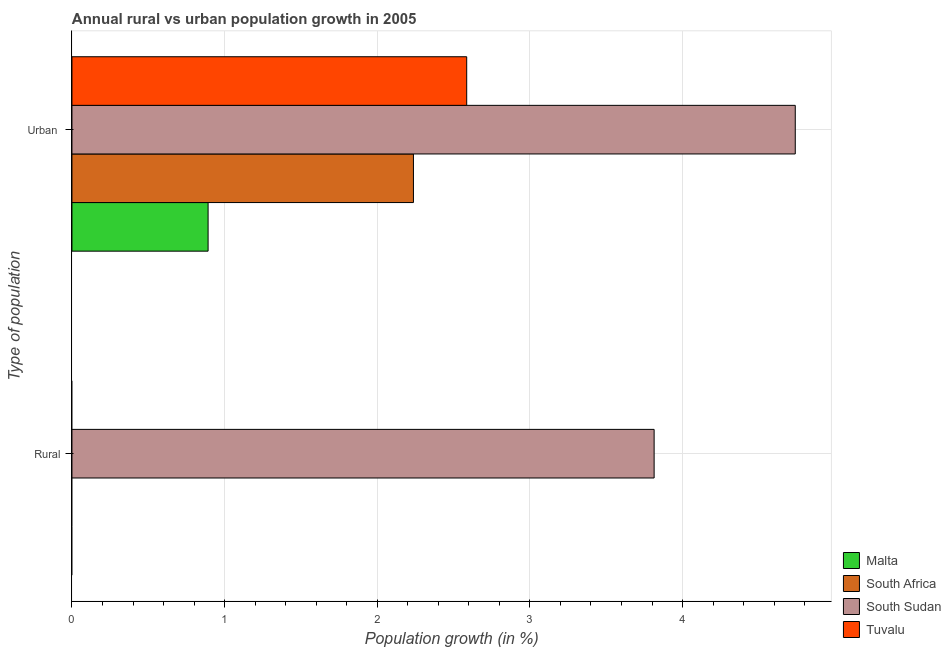How many different coloured bars are there?
Give a very brief answer. 4. Are the number of bars on each tick of the Y-axis equal?
Your answer should be compact. No. How many bars are there on the 1st tick from the top?
Give a very brief answer. 4. What is the label of the 1st group of bars from the top?
Make the answer very short. Urban . What is the urban population growth in Malta?
Ensure brevity in your answer.  0.89. Across all countries, what is the maximum rural population growth?
Ensure brevity in your answer.  3.81. Across all countries, what is the minimum urban population growth?
Offer a terse response. 0.89. In which country was the urban population growth maximum?
Offer a terse response. South Sudan. What is the total urban population growth in the graph?
Provide a succinct answer. 10.45. What is the difference between the urban population growth in South Africa and that in Tuvalu?
Provide a short and direct response. -0.35. What is the difference between the urban population growth in Malta and the rural population growth in Tuvalu?
Make the answer very short. 0.89. What is the average urban population growth per country?
Provide a succinct answer. 2.61. What is the ratio of the urban population growth in South Sudan to that in South Africa?
Ensure brevity in your answer.  2.12. How many bars are there?
Offer a terse response. 5. Are all the bars in the graph horizontal?
Your answer should be very brief. Yes. What is the difference between two consecutive major ticks on the X-axis?
Keep it short and to the point. 1. Does the graph contain any zero values?
Your answer should be compact. Yes. Does the graph contain grids?
Provide a succinct answer. Yes. How many legend labels are there?
Your answer should be very brief. 4. What is the title of the graph?
Provide a short and direct response. Annual rural vs urban population growth in 2005. What is the label or title of the X-axis?
Your answer should be compact. Population growth (in %). What is the label or title of the Y-axis?
Give a very brief answer. Type of population. What is the Population growth (in %) in South Sudan in Rural?
Offer a terse response. 3.81. What is the Population growth (in %) in Tuvalu in Rural?
Ensure brevity in your answer.  0. What is the Population growth (in %) of Malta in Urban ?
Your response must be concise. 0.89. What is the Population growth (in %) of South Africa in Urban ?
Offer a terse response. 2.24. What is the Population growth (in %) of South Sudan in Urban ?
Keep it short and to the point. 4.74. What is the Population growth (in %) of Tuvalu in Urban ?
Your answer should be very brief. 2.59. Across all Type of population, what is the maximum Population growth (in %) in Malta?
Provide a short and direct response. 0.89. Across all Type of population, what is the maximum Population growth (in %) in South Africa?
Your response must be concise. 2.24. Across all Type of population, what is the maximum Population growth (in %) of South Sudan?
Offer a terse response. 4.74. Across all Type of population, what is the maximum Population growth (in %) in Tuvalu?
Provide a succinct answer. 2.59. Across all Type of population, what is the minimum Population growth (in %) of South Africa?
Offer a terse response. 0. Across all Type of population, what is the minimum Population growth (in %) of South Sudan?
Give a very brief answer. 3.81. What is the total Population growth (in %) in Malta in the graph?
Your response must be concise. 0.89. What is the total Population growth (in %) in South Africa in the graph?
Give a very brief answer. 2.24. What is the total Population growth (in %) in South Sudan in the graph?
Ensure brevity in your answer.  8.55. What is the total Population growth (in %) of Tuvalu in the graph?
Give a very brief answer. 2.59. What is the difference between the Population growth (in %) in South Sudan in Rural and that in Urban ?
Offer a very short reply. -0.92. What is the difference between the Population growth (in %) in South Sudan in Rural and the Population growth (in %) in Tuvalu in Urban ?
Give a very brief answer. 1.23. What is the average Population growth (in %) in Malta per Type of population?
Your response must be concise. 0.45. What is the average Population growth (in %) of South Africa per Type of population?
Provide a short and direct response. 1.12. What is the average Population growth (in %) in South Sudan per Type of population?
Provide a short and direct response. 4.28. What is the average Population growth (in %) in Tuvalu per Type of population?
Give a very brief answer. 1.29. What is the difference between the Population growth (in %) of Malta and Population growth (in %) of South Africa in Urban ?
Offer a terse response. -1.35. What is the difference between the Population growth (in %) of Malta and Population growth (in %) of South Sudan in Urban ?
Ensure brevity in your answer.  -3.85. What is the difference between the Population growth (in %) in Malta and Population growth (in %) in Tuvalu in Urban ?
Your response must be concise. -1.69. What is the difference between the Population growth (in %) in South Africa and Population growth (in %) in South Sudan in Urban ?
Make the answer very short. -2.5. What is the difference between the Population growth (in %) of South Africa and Population growth (in %) of Tuvalu in Urban ?
Your answer should be very brief. -0.35. What is the difference between the Population growth (in %) of South Sudan and Population growth (in %) of Tuvalu in Urban ?
Keep it short and to the point. 2.15. What is the ratio of the Population growth (in %) in South Sudan in Rural to that in Urban ?
Offer a terse response. 0.8. What is the difference between the highest and the second highest Population growth (in %) of South Sudan?
Give a very brief answer. 0.92. What is the difference between the highest and the lowest Population growth (in %) in Malta?
Your answer should be compact. 0.89. What is the difference between the highest and the lowest Population growth (in %) of South Africa?
Provide a succinct answer. 2.24. What is the difference between the highest and the lowest Population growth (in %) of South Sudan?
Keep it short and to the point. 0.92. What is the difference between the highest and the lowest Population growth (in %) of Tuvalu?
Offer a very short reply. 2.59. 